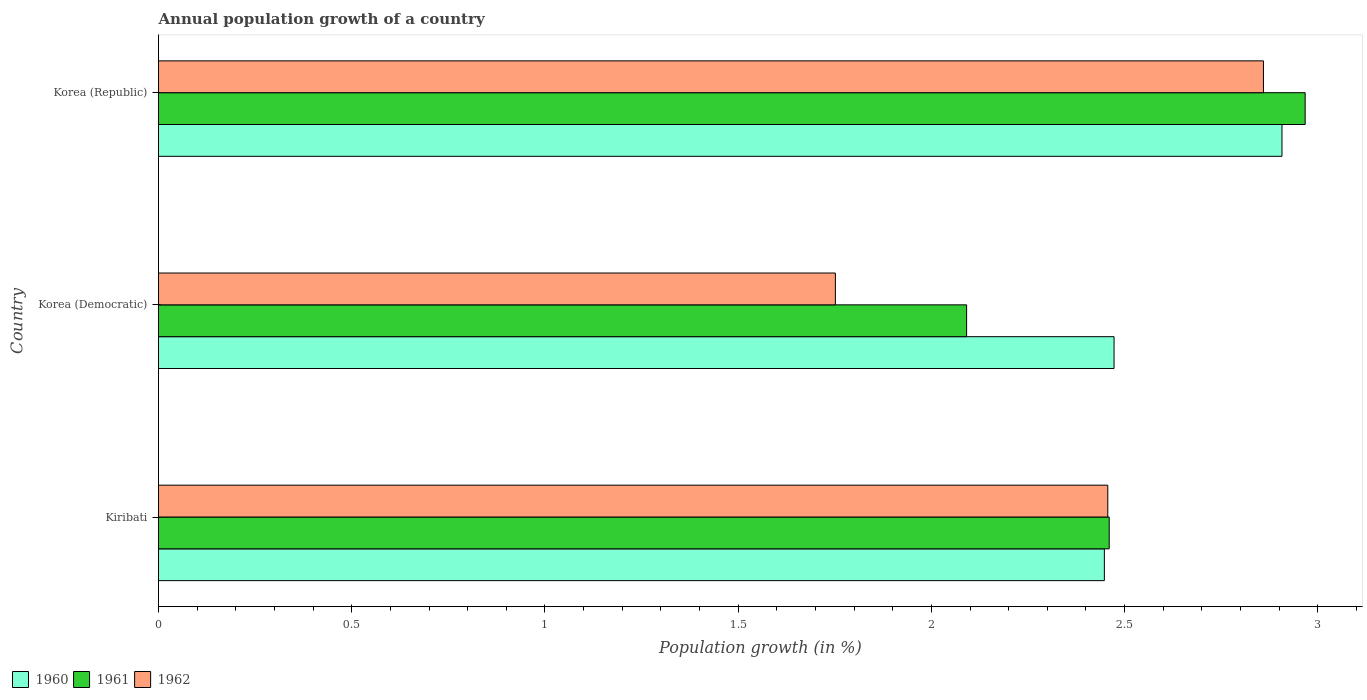How many groups of bars are there?
Offer a very short reply. 3. How many bars are there on the 3rd tick from the top?
Your response must be concise. 3. What is the label of the 2nd group of bars from the top?
Ensure brevity in your answer.  Korea (Democratic). In how many cases, is the number of bars for a given country not equal to the number of legend labels?
Make the answer very short. 0. What is the annual population growth in 1962 in Korea (Democratic)?
Provide a succinct answer. 1.75. Across all countries, what is the maximum annual population growth in 1961?
Your response must be concise. 2.97. Across all countries, what is the minimum annual population growth in 1961?
Provide a succinct answer. 2.09. In which country was the annual population growth in 1960 minimum?
Make the answer very short. Kiribati. What is the total annual population growth in 1962 in the graph?
Make the answer very short. 7.07. What is the difference between the annual population growth in 1962 in Korea (Democratic) and that in Korea (Republic)?
Make the answer very short. -1.11. What is the difference between the annual population growth in 1962 in Korea (Democratic) and the annual population growth in 1960 in Kiribati?
Your answer should be very brief. -0.7. What is the average annual population growth in 1960 per country?
Provide a succinct answer. 2.61. What is the difference between the annual population growth in 1961 and annual population growth in 1962 in Kiribati?
Your answer should be compact. 0. In how many countries, is the annual population growth in 1962 greater than 2.4 %?
Your answer should be compact. 2. What is the ratio of the annual population growth in 1961 in Korea (Democratic) to that in Korea (Republic)?
Your answer should be very brief. 0.7. Is the difference between the annual population growth in 1961 in Korea (Democratic) and Korea (Republic) greater than the difference between the annual population growth in 1962 in Korea (Democratic) and Korea (Republic)?
Give a very brief answer. Yes. What is the difference between the highest and the second highest annual population growth in 1961?
Your answer should be compact. 0.51. What is the difference between the highest and the lowest annual population growth in 1960?
Offer a very short reply. 0.46. What does the 3rd bar from the bottom in Korea (Republic) represents?
Your answer should be very brief. 1962. How many bars are there?
Provide a short and direct response. 9. Are all the bars in the graph horizontal?
Make the answer very short. Yes. How many countries are there in the graph?
Your response must be concise. 3. Are the values on the major ticks of X-axis written in scientific E-notation?
Provide a short and direct response. No. What is the title of the graph?
Give a very brief answer. Annual population growth of a country. Does "1967" appear as one of the legend labels in the graph?
Give a very brief answer. No. What is the label or title of the X-axis?
Keep it short and to the point. Population growth (in %). What is the Population growth (in %) of 1960 in Kiribati?
Ensure brevity in your answer.  2.45. What is the Population growth (in %) in 1961 in Kiribati?
Make the answer very short. 2.46. What is the Population growth (in %) in 1962 in Kiribati?
Provide a short and direct response. 2.46. What is the Population growth (in %) in 1960 in Korea (Democratic)?
Your answer should be compact. 2.47. What is the Population growth (in %) of 1961 in Korea (Democratic)?
Your answer should be very brief. 2.09. What is the Population growth (in %) of 1962 in Korea (Democratic)?
Provide a short and direct response. 1.75. What is the Population growth (in %) in 1960 in Korea (Republic)?
Make the answer very short. 2.91. What is the Population growth (in %) in 1961 in Korea (Republic)?
Give a very brief answer. 2.97. What is the Population growth (in %) in 1962 in Korea (Republic)?
Keep it short and to the point. 2.86. Across all countries, what is the maximum Population growth (in %) in 1960?
Offer a terse response. 2.91. Across all countries, what is the maximum Population growth (in %) in 1961?
Your answer should be compact. 2.97. Across all countries, what is the maximum Population growth (in %) of 1962?
Your response must be concise. 2.86. Across all countries, what is the minimum Population growth (in %) in 1960?
Provide a succinct answer. 2.45. Across all countries, what is the minimum Population growth (in %) in 1961?
Make the answer very short. 2.09. Across all countries, what is the minimum Population growth (in %) of 1962?
Make the answer very short. 1.75. What is the total Population growth (in %) of 1960 in the graph?
Offer a very short reply. 7.83. What is the total Population growth (in %) in 1961 in the graph?
Provide a succinct answer. 7.52. What is the total Population growth (in %) in 1962 in the graph?
Offer a very short reply. 7.07. What is the difference between the Population growth (in %) of 1960 in Kiribati and that in Korea (Democratic)?
Offer a terse response. -0.03. What is the difference between the Population growth (in %) of 1961 in Kiribati and that in Korea (Democratic)?
Give a very brief answer. 0.37. What is the difference between the Population growth (in %) of 1962 in Kiribati and that in Korea (Democratic)?
Provide a short and direct response. 0.7. What is the difference between the Population growth (in %) in 1960 in Kiribati and that in Korea (Republic)?
Offer a terse response. -0.46. What is the difference between the Population growth (in %) of 1961 in Kiribati and that in Korea (Republic)?
Your response must be concise. -0.51. What is the difference between the Population growth (in %) in 1962 in Kiribati and that in Korea (Republic)?
Your answer should be compact. -0.4. What is the difference between the Population growth (in %) of 1960 in Korea (Democratic) and that in Korea (Republic)?
Give a very brief answer. -0.43. What is the difference between the Population growth (in %) of 1961 in Korea (Democratic) and that in Korea (Republic)?
Give a very brief answer. -0.88. What is the difference between the Population growth (in %) in 1962 in Korea (Democratic) and that in Korea (Republic)?
Provide a short and direct response. -1.11. What is the difference between the Population growth (in %) in 1960 in Kiribati and the Population growth (in %) in 1961 in Korea (Democratic)?
Keep it short and to the point. 0.36. What is the difference between the Population growth (in %) of 1960 in Kiribati and the Population growth (in %) of 1962 in Korea (Democratic)?
Provide a succinct answer. 0.7. What is the difference between the Population growth (in %) in 1961 in Kiribati and the Population growth (in %) in 1962 in Korea (Democratic)?
Ensure brevity in your answer.  0.71. What is the difference between the Population growth (in %) in 1960 in Kiribati and the Population growth (in %) in 1961 in Korea (Republic)?
Your response must be concise. -0.52. What is the difference between the Population growth (in %) in 1960 in Kiribati and the Population growth (in %) in 1962 in Korea (Republic)?
Offer a terse response. -0.41. What is the difference between the Population growth (in %) in 1961 in Kiribati and the Population growth (in %) in 1962 in Korea (Republic)?
Ensure brevity in your answer.  -0.4. What is the difference between the Population growth (in %) of 1960 in Korea (Democratic) and the Population growth (in %) of 1961 in Korea (Republic)?
Keep it short and to the point. -0.49. What is the difference between the Population growth (in %) of 1960 in Korea (Democratic) and the Population growth (in %) of 1962 in Korea (Republic)?
Give a very brief answer. -0.39. What is the difference between the Population growth (in %) in 1961 in Korea (Democratic) and the Population growth (in %) in 1962 in Korea (Republic)?
Give a very brief answer. -0.77. What is the average Population growth (in %) in 1960 per country?
Provide a succinct answer. 2.61. What is the average Population growth (in %) in 1961 per country?
Provide a short and direct response. 2.51. What is the average Population growth (in %) of 1962 per country?
Give a very brief answer. 2.36. What is the difference between the Population growth (in %) in 1960 and Population growth (in %) in 1961 in Kiribati?
Provide a short and direct response. -0.01. What is the difference between the Population growth (in %) in 1960 and Population growth (in %) in 1962 in Kiribati?
Offer a terse response. -0.01. What is the difference between the Population growth (in %) of 1961 and Population growth (in %) of 1962 in Kiribati?
Your answer should be very brief. 0. What is the difference between the Population growth (in %) of 1960 and Population growth (in %) of 1961 in Korea (Democratic)?
Offer a very short reply. 0.38. What is the difference between the Population growth (in %) of 1960 and Population growth (in %) of 1962 in Korea (Democratic)?
Offer a terse response. 0.72. What is the difference between the Population growth (in %) in 1961 and Population growth (in %) in 1962 in Korea (Democratic)?
Ensure brevity in your answer.  0.34. What is the difference between the Population growth (in %) in 1960 and Population growth (in %) in 1961 in Korea (Republic)?
Offer a terse response. -0.06. What is the difference between the Population growth (in %) in 1960 and Population growth (in %) in 1962 in Korea (Republic)?
Your response must be concise. 0.05. What is the difference between the Population growth (in %) of 1961 and Population growth (in %) of 1962 in Korea (Republic)?
Keep it short and to the point. 0.11. What is the ratio of the Population growth (in %) of 1960 in Kiribati to that in Korea (Democratic)?
Give a very brief answer. 0.99. What is the ratio of the Population growth (in %) in 1961 in Kiribati to that in Korea (Democratic)?
Provide a succinct answer. 1.18. What is the ratio of the Population growth (in %) of 1962 in Kiribati to that in Korea (Democratic)?
Offer a terse response. 1.4. What is the ratio of the Population growth (in %) in 1960 in Kiribati to that in Korea (Republic)?
Your answer should be compact. 0.84. What is the ratio of the Population growth (in %) in 1961 in Kiribati to that in Korea (Republic)?
Your answer should be compact. 0.83. What is the ratio of the Population growth (in %) of 1962 in Kiribati to that in Korea (Republic)?
Ensure brevity in your answer.  0.86. What is the ratio of the Population growth (in %) of 1960 in Korea (Democratic) to that in Korea (Republic)?
Provide a succinct answer. 0.85. What is the ratio of the Population growth (in %) in 1961 in Korea (Democratic) to that in Korea (Republic)?
Your answer should be very brief. 0.7. What is the ratio of the Population growth (in %) of 1962 in Korea (Democratic) to that in Korea (Republic)?
Ensure brevity in your answer.  0.61. What is the difference between the highest and the second highest Population growth (in %) of 1960?
Give a very brief answer. 0.43. What is the difference between the highest and the second highest Population growth (in %) of 1961?
Offer a terse response. 0.51. What is the difference between the highest and the second highest Population growth (in %) in 1962?
Keep it short and to the point. 0.4. What is the difference between the highest and the lowest Population growth (in %) in 1960?
Your response must be concise. 0.46. What is the difference between the highest and the lowest Population growth (in %) in 1961?
Make the answer very short. 0.88. What is the difference between the highest and the lowest Population growth (in %) in 1962?
Make the answer very short. 1.11. 